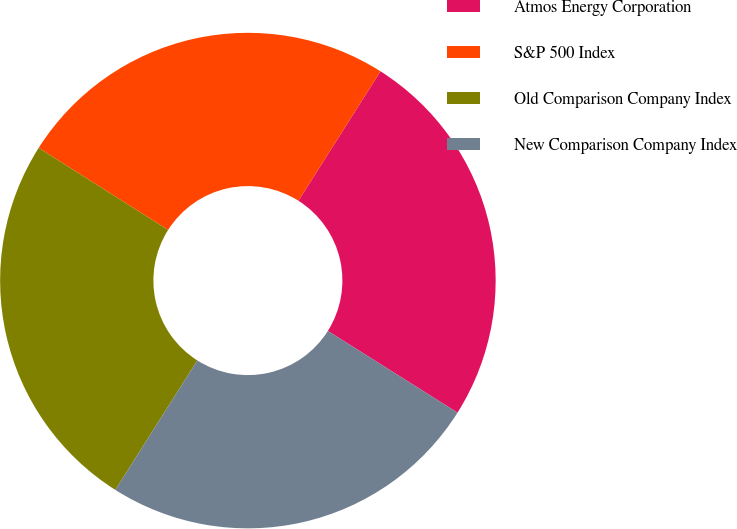<chart> <loc_0><loc_0><loc_500><loc_500><pie_chart><fcel>Atmos Energy Corporation<fcel>S&P 500 Index<fcel>Old Comparison Company Index<fcel>New Comparison Company Index<nl><fcel>24.96%<fcel>24.99%<fcel>25.01%<fcel>25.04%<nl></chart> 